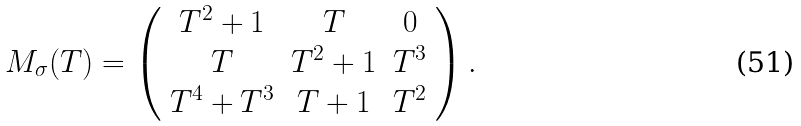<formula> <loc_0><loc_0><loc_500><loc_500>M _ { \sigma } ( T ) = \left ( \begin{array} { c c c c } T ^ { 2 } + 1 & T & 0 \\ T & T ^ { 2 } + 1 & T ^ { 3 } \\ T ^ { 4 } + T ^ { 3 } & T + 1 & T ^ { 2 } \\ \end{array} \right ) .</formula> 